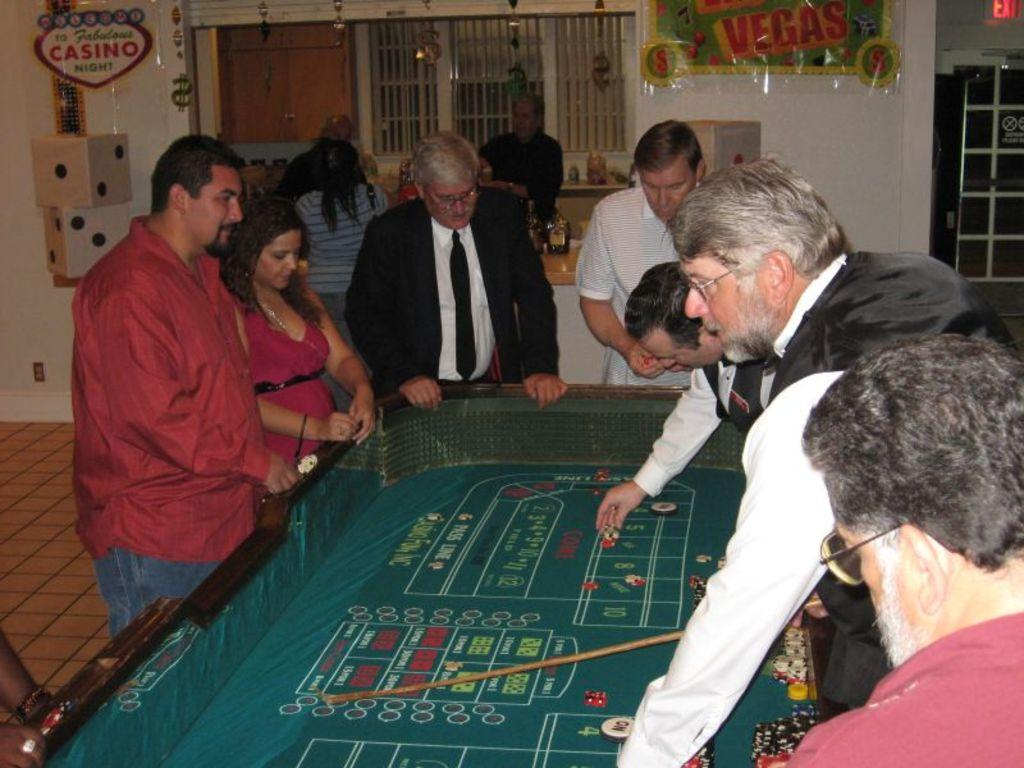How many people are in the image? There is a group of people in the image, but the exact number is not specified. What are the people doing in the image? The people are standing in front of a table. What can be seen in the background of the image? There are boards attached to the wall in the background of the image. What type of pencil is being used by the person in the image? There is no pencil present in the image; the people are standing in front of a table, but no writing or drawing tools are visible. 